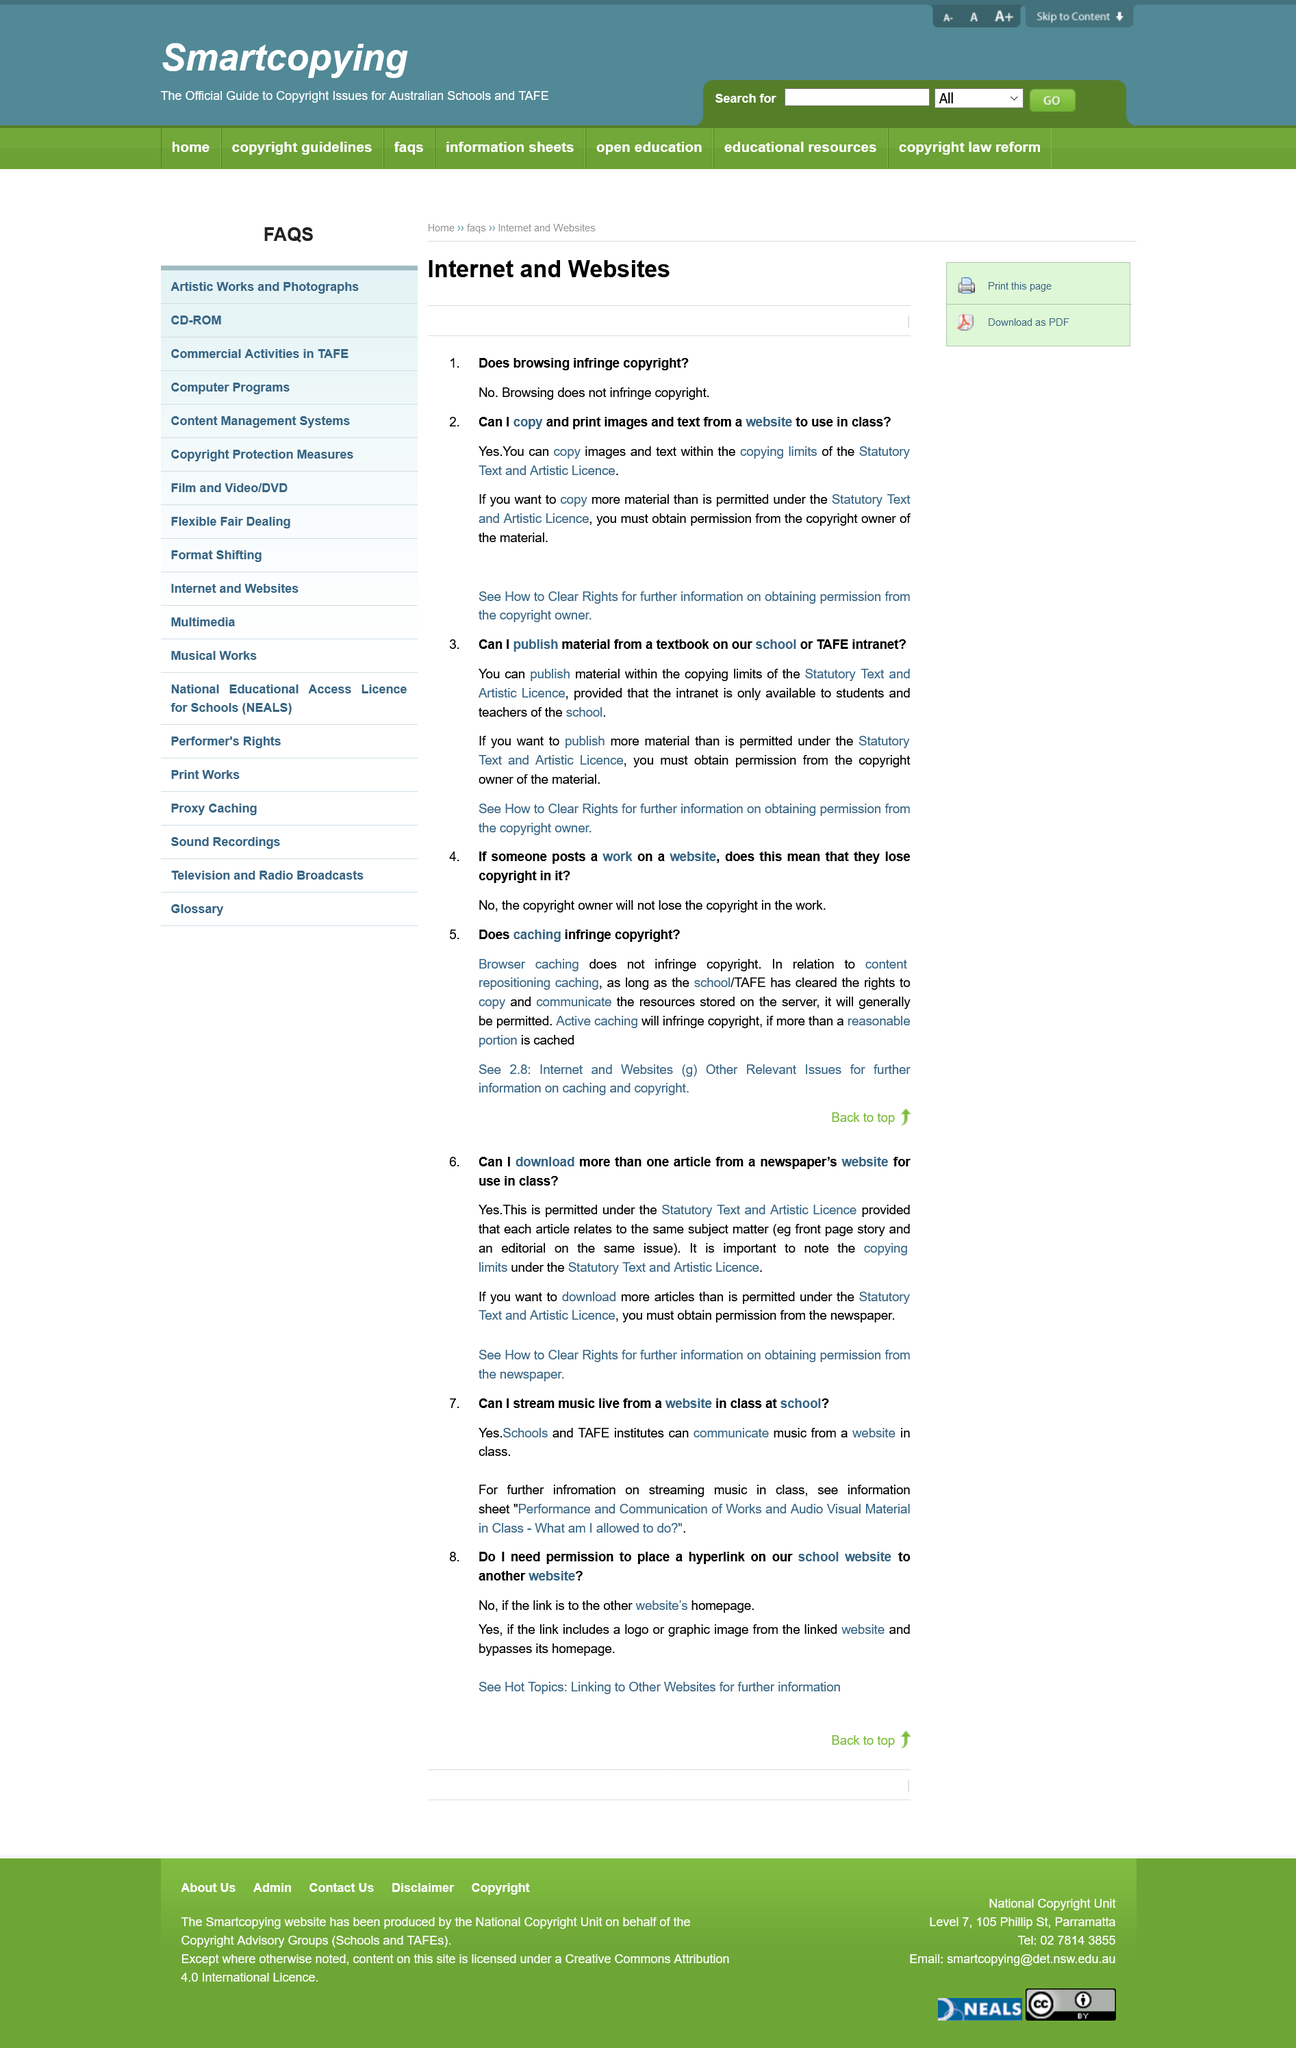Outline some significant characteristics in this image. Schools and TAFE institutes can communicate music from a website in class. A hyperlink on a school website can be placed to another website in certain circumstances, such as when the link includes a logo or graphic image from the linked website and bypasses the home page. You are able to copy and print images and text from a website for educational purposes, as long as you comply with the limits set by the Statutory Text and Artistic Licence. Browsing does not infringe copyright. I am encouraged to read the "Performance and Communication of Works and Audio Visual Material in Class - What Am I Allowed to Do?" information sheet for further information on streaming music in class. 